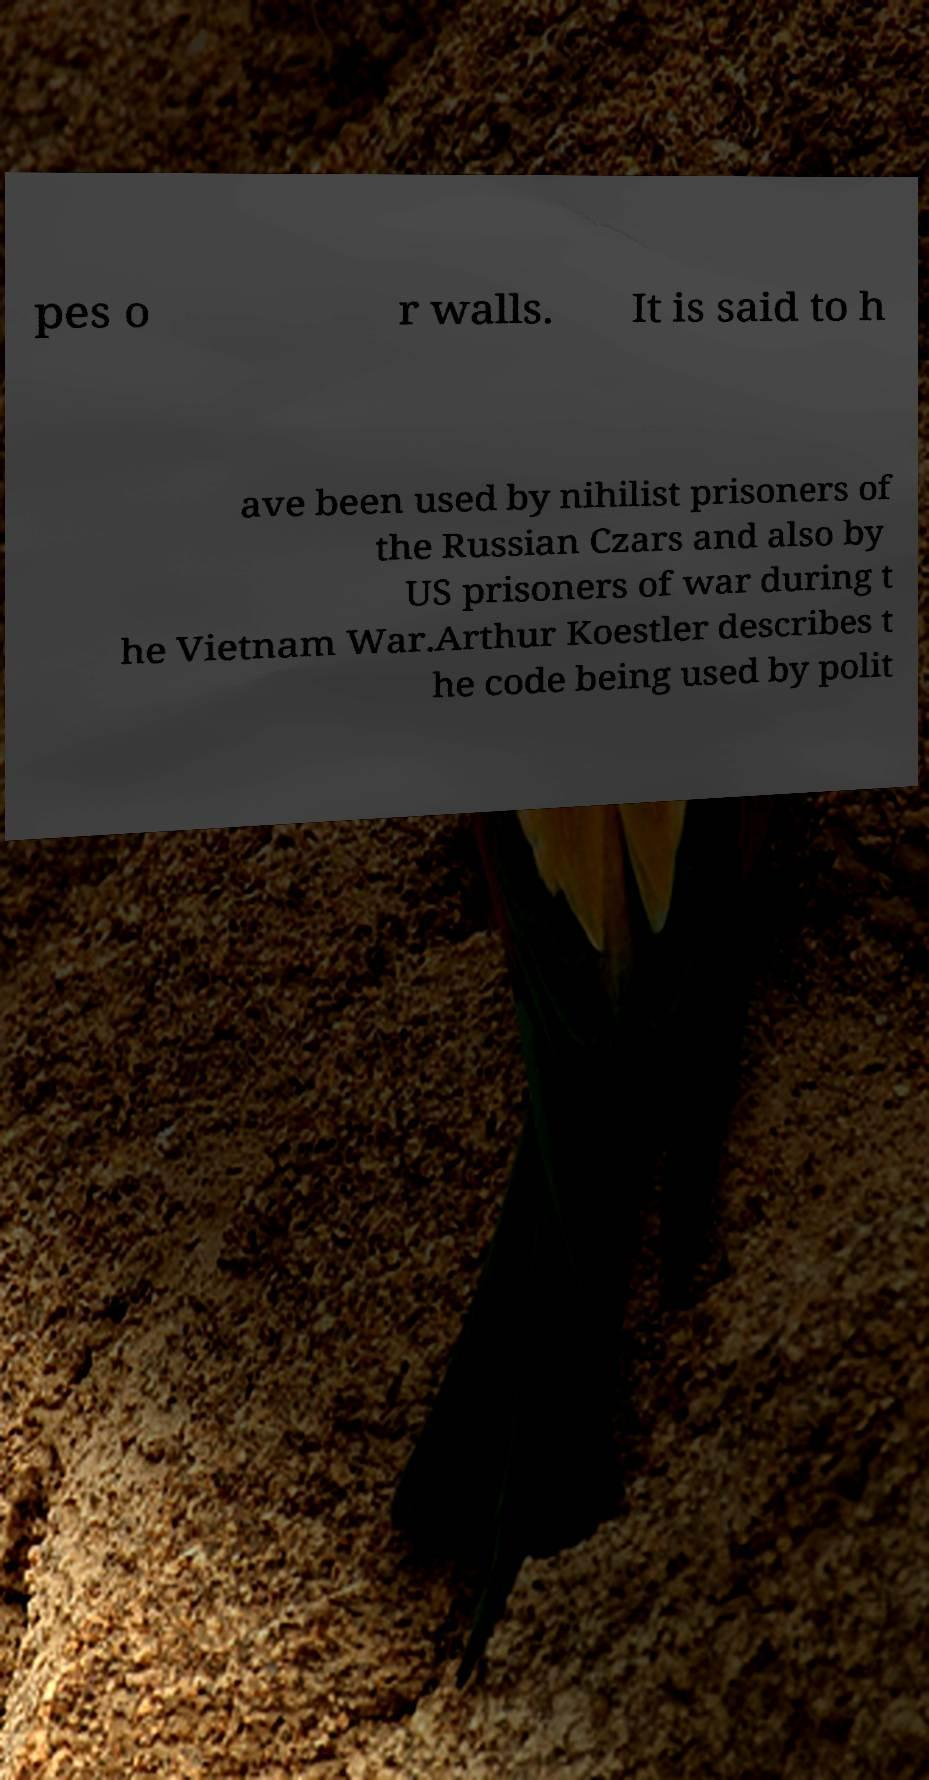For documentation purposes, I need the text within this image transcribed. Could you provide that? pes o r walls. It is said to h ave been used by nihilist prisoners of the Russian Czars and also by US prisoners of war during t he Vietnam War.Arthur Koestler describes t he code being used by polit 